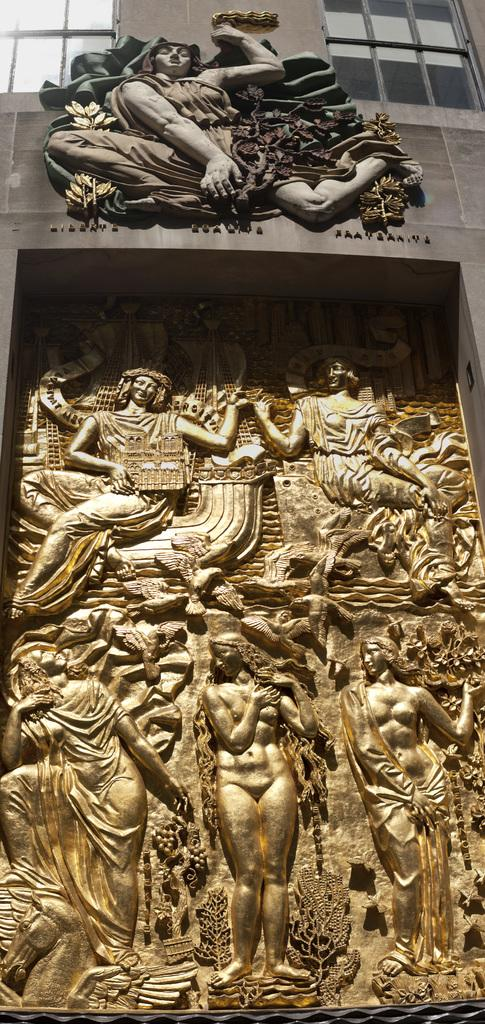What is depicted in the image? There is a carving of people in the image. What else can be seen in the carving? There are objects in the carving. What is located at the top of the image? There is a wall and glass windows at the top of the image. What type of shelf can be seen in the carving? There is no shelf present in the carving; it features people and objects. What sense is being evoked by the scene in the image? The image is visual, so it primarily evokes the sense of sight. 